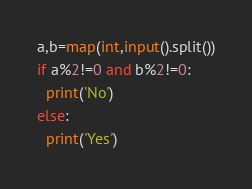Convert code to text. <code><loc_0><loc_0><loc_500><loc_500><_Python_>a,b=map(int,input().split())
if a%2!=0 and b%2!=0:
  print('No')
else:
  print('Yes')</code> 